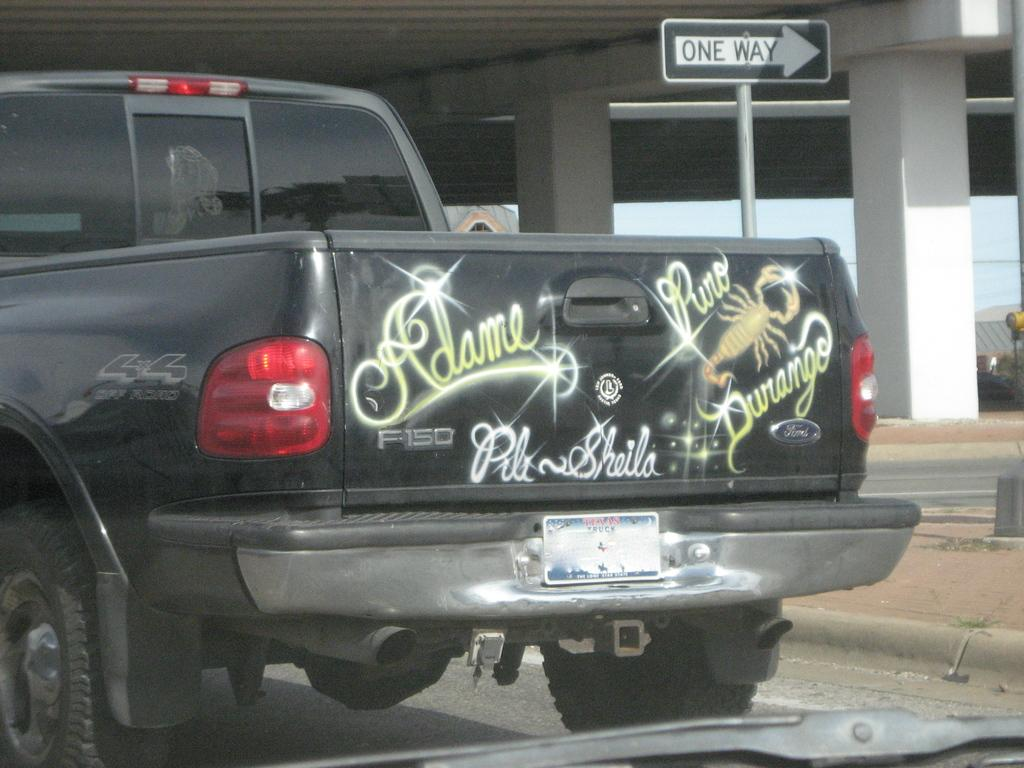What is the main subject of the image? The main subject of the image is a truck. What is the truck doing in the image? The truck is moving on the road in the image. What can be seen in the background of the image? There is a bridge in the background of the image. What type of creature is talking to the truck driver in the image? There is no creature present in the image, and the truck driver is not shown talking to anyone. 